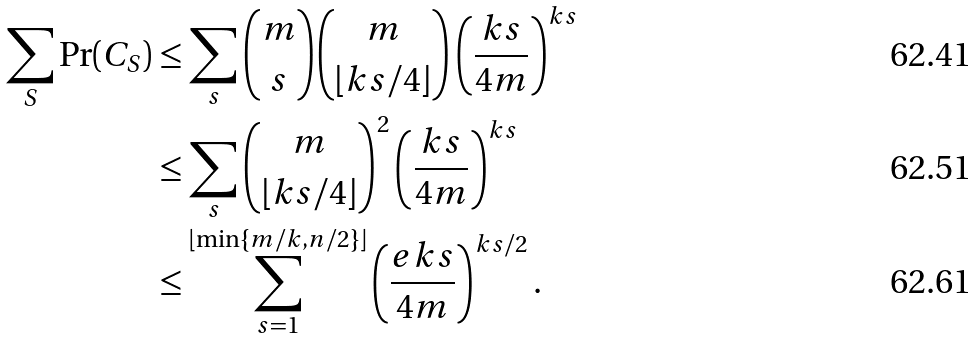Convert formula to latex. <formula><loc_0><loc_0><loc_500><loc_500>\sum _ { S } \Pr ( C _ { S } ) & \leq \sum _ { s } \binom { m } { s } \binom { m } { \lfloor k s / 4 \rfloor } \left ( \frac { k s } { 4 m } \right ) ^ { k s } \\ & \leq \sum _ { s } \binom { m } { \lfloor k s / 4 \rfloor } ^ { 2 } \left ( \frac { k s } { 4 m } \right ) ^ { k s } \\ & \leq \sum _ { s = 1 } ^ { \lfloor \min \{ m / k , n / 2 \} \rfloor } \left ( \frac { e k s } { 4 m } \right ) ^ { k s / 2 } .</formula> 